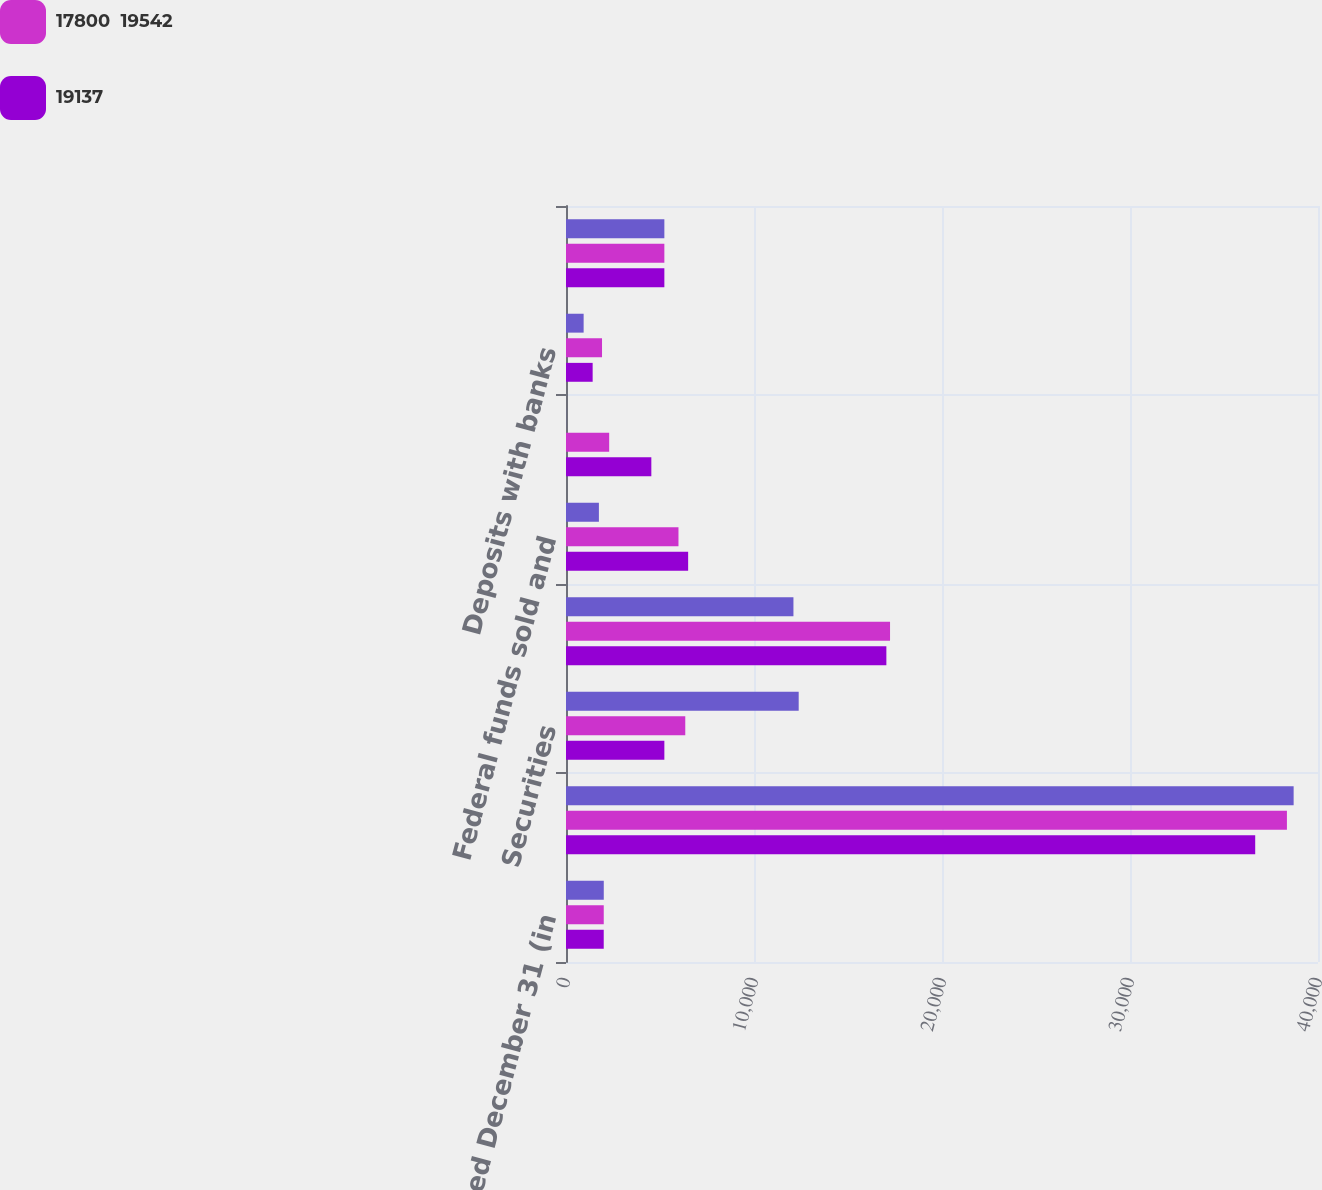Convert chart to OTSL. <chart><loc_0><loc_0><loc_500><loc_500><stacked_bar_chart><ecel><fcel>Year ended December 31 (in<fcel>Loans<fcel>Securities<fcel>Trading assets<fcel>Federal funds sold and<fcel>Securities borrowed<fcel>Deposits with banks<fcel>Total interest income<nl><fcel>nan<fcel>2009<fcel>38704<fcel>12377<fcel>12098<fcel>1750<fcel>4<fcel>938<fcel>5232<nl><fcel>17800  19542<fcel>2008<fcel>38347<fcel>6344<fcel>17236<fcel>5983<fcel>2297<fcel>1916<fcel>5232<nl><fcel>19137<fcel>2007<fcel>36660<fcel>5232<fcel>17041<fcel>6497<fcel>4539<fcel>1418<fcel>5232<nl></chart> 